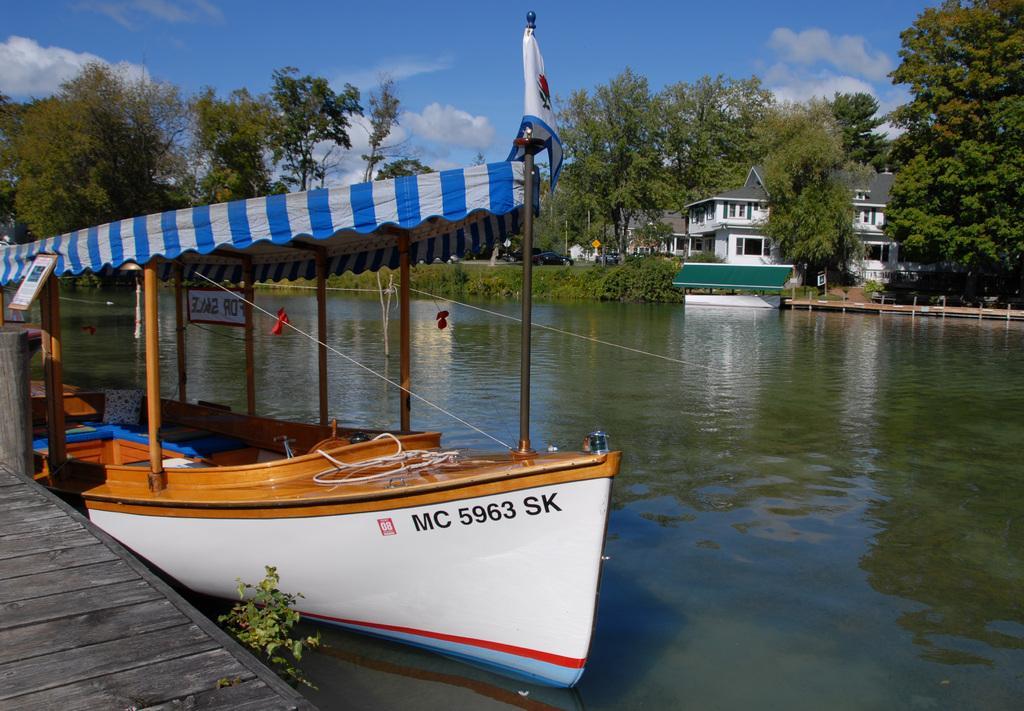How would you summarize this image in a sentence or two? In this image we can see a watercraft and we can see some text on it. We can see the reflections of trees and a watercraft on the water surface. There is a lake in the image. There are many trees and plants in the image. There are few buildings in the image. There is a board at the left side of the image. There is a wooden surface at the bottom left corner of the image. 